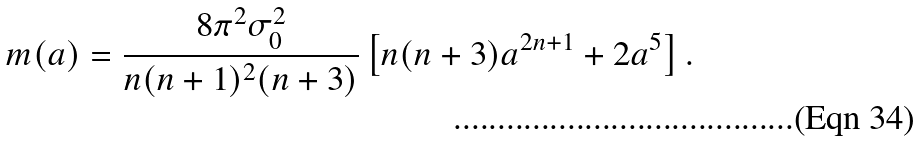<formula> <loc_0><loc_0><loc_500><loc_500>m ( a ) = \frac { 8 \pi ^ { 2 } \sigma _ { 0 } ^ { 2 } } { n { ( n + 1 ) ^ { 2 } } ( n + 3 ) } \left [ n ( n + 3 ) a ^ { 2 n + 1 } + 2 a ^ { 5 } \right ] .</formula> 